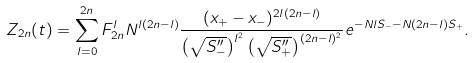<formula> <loc_0><loc_0><loc_500><loc_500>Z _ { 2 n } ( t ) = \sum _ { l = 0 } ^ { 2 n } F ^ { l } _ { 2 n } N ^ { l ( 2 n - l ) } \frac { ( x _ { + } - x _ { - } ) ^ { 2 l ( 2 n - l ) } } { \left ( \sqrt { S ^ { \prime \prime } _ { - } } \right ) ^ { l ^ { 2 } } \left ( \sqrt { S ^ { \prime \prime } _ { + } } \right ) ^ { ( 2 n - l ) ^ { 2 } } } e ^ { - N l S _ { - } - N ( 2 n - l ) S _ { + } } .</formula> 